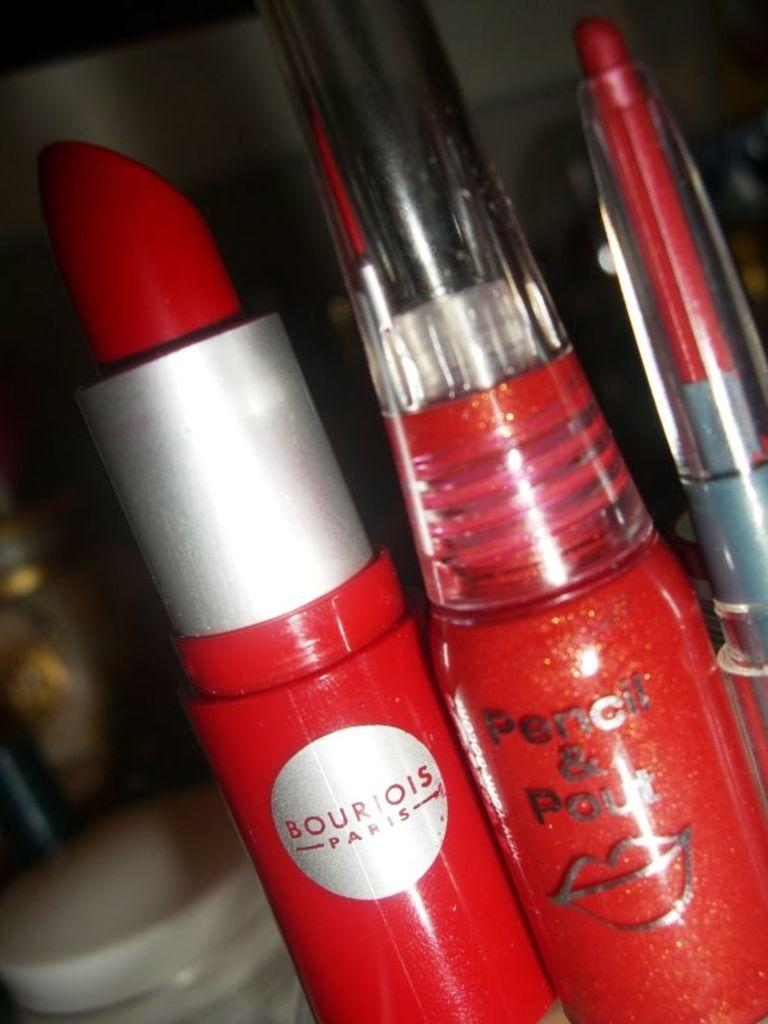What type of cosmetic product is present in the image? There are three red color lipsticks in the image. Can you describe the color of the lipsticks? The lipsticks are red in color. What can be seen in the background of the image? There are white color objects in the background of the image. How many ducks are present in the image? There are no ducks present in the image; it only features lipsticks and white objects in the background. 